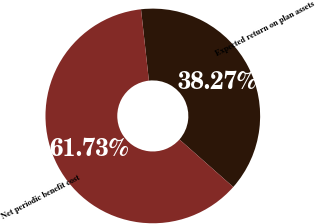Convert chart. <chart><loc_0><loc_0><loc_500><loc_500><pie_chart><fcel>Expected return on plan assets<fcel>Net periodic benefit cost<nl><fcel>38.27%<fcel>61.73%<nl></chart> 